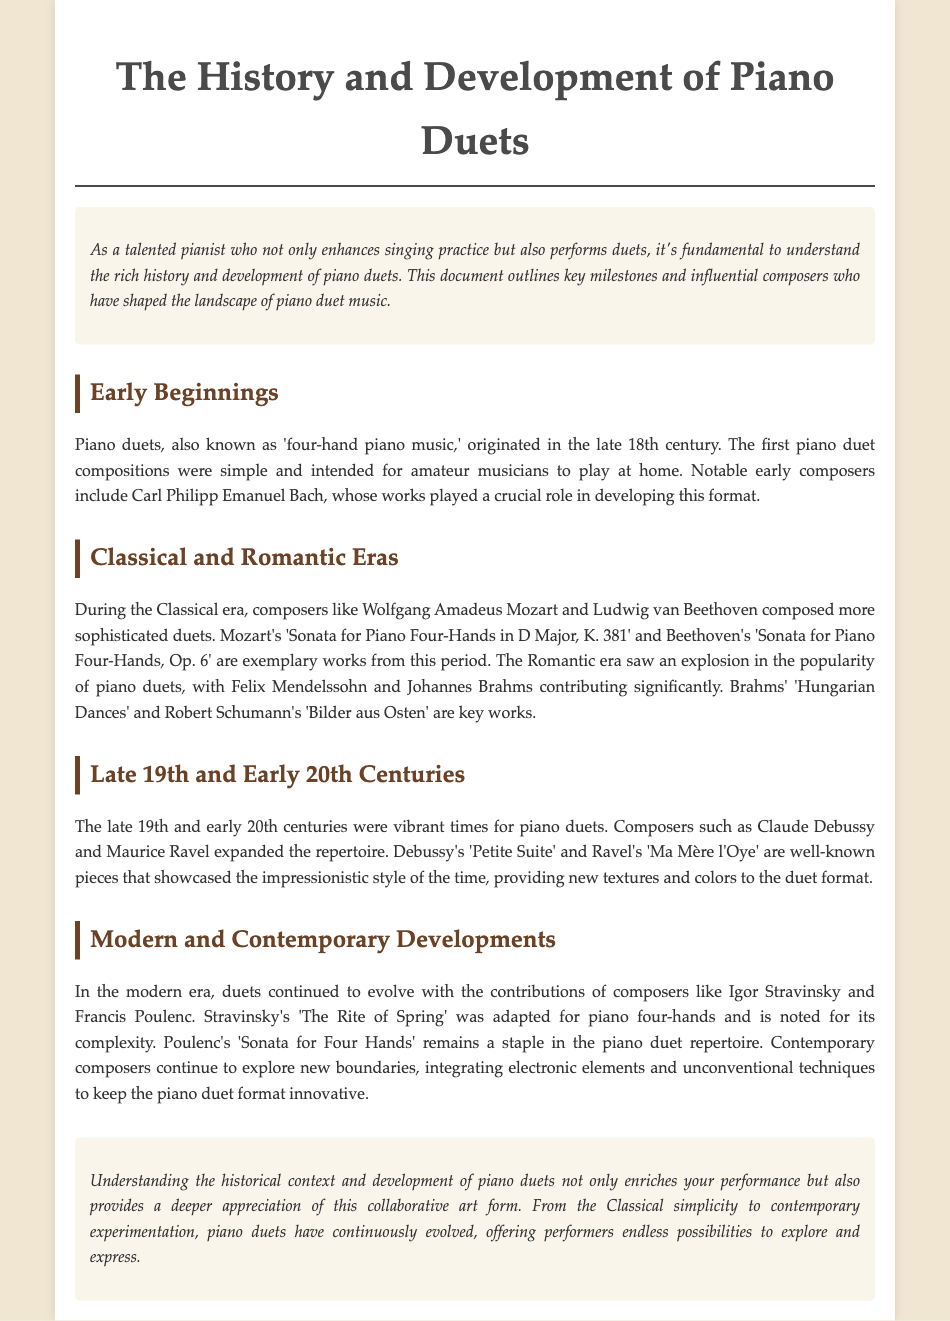What is the primary focus of the document? The document outlines the history and development of piano duets, highlighting key milestones and composers.
Answer: History and development of piano duets Who were the early composers mentioned? The document specifically names Carl Philipp Emanuel Bach as a notable early composer of piano duets.
Answer: Carl Philipp Emanuel Bach Which Mozart composition is cited? The document references Mozart's "Sonata for Piano Four-Hands in D Major, K. 381" as an exemplary work from the Classical era.
Answer: Sonata for Piano Four-Hands in D Major, K. 381 What style did Debussy and Ravel's works showcase? The document indicates that Debussy and Ravel's pieces showcased the impressionistic style, adding new textures and colors.
Answer: Impressionistic style What is a significant work by Brahms mentioned in the document? The document lists Brahms' "Hungarian Dances" as a key work in the piano duet repertoire from the Romantic era.
Answer: Hungarian Dances Which period saw an increase in the popularity of piano duets? The document states that the Romantic era experienced an explosion in the popularity of piano duets.
Answer: Romantic era Who is noted for adapting "The Rite of Spring" for piano four-hands? The document names Igor Stravinsky as the composer who adapted "The Rite of Spring" for piano four-hands.
Answer: Igor Stravinsky What thematic elements do contemporary composers integrate into piano duets? The document mentions that contemporary composers explore new boundaries by integrating electronic elements and unconventional techniques.
Answer: Electronic elements and unconventional techniques 